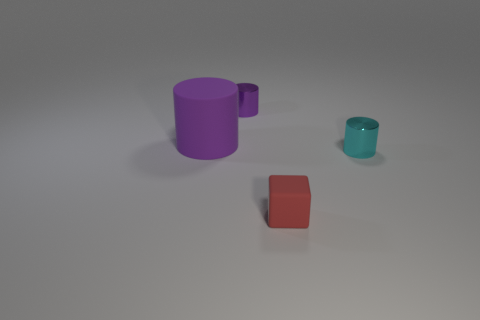Add 4 brown cylinders. How many objects exist? 8 Subtract all cubes. How many objects are left? 3 Subtract all purple rubber objects. Subtract all small cyan shiny cylinders. How many objects are left? 2 Add 2 small red rubber objects. How many small red rubber objects are left? 3 Add 3 small blue metallic cylinders. How many small blue metallic cylinders exist? 3 Subtract 2 purple cylinders. How many objects are left? 2 